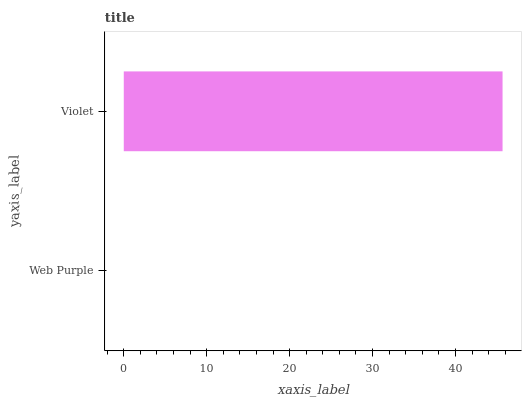Is Web Purple the minimum?
Answer yes or no. Yes. Is Violet the maximum?
Answer yes or no. Yes. Is Violet the minimum?
Answer yes or no. No. Is Violet greater than Web Purple?
Answer yes or no. Yes. Is Web Purple less than Violet?
Answer yes or no. Yes. Is Web Purple greater than Violet?
Answer yes or no. No. Is Violet less than Web Purple?
Answer yes or no. No. Is Violet the high median?
Answer yes or no. Yes. Is Web Purple the low median?
Answer yes or no. Yes. Is Web Purple the high median?
Answer yes or no. No. Is Violet the low median?
Answer yes or no. No. 